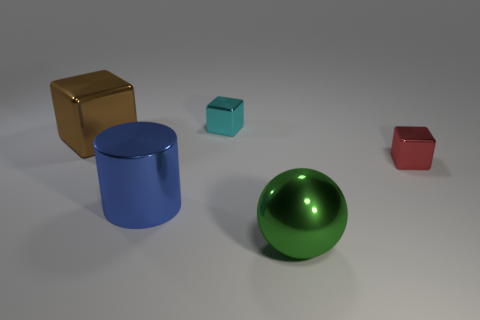Subtract all small cubes. How many cubes are left? 1 Subtract all brown cubes. How many cubes are left? 2 Add 4 brown shiny things. How many objects exist? 9 Subtract all blocks. How many objects are left? 2 Subtract all brown cylinders. How many brown blocks are left? 1 Subtract all tiny purple metallic cylinders. Subtract all tiny cyan objects. How many objects are left? 4 Add 5 green metal things. How many green metal things are left? 6 Add 2 big cylinders. How many big cylinders exist? 3 Subtract 1 green spheres. How many objects are left? 4 Subtract all red blocks. Subtract all green spheres. How many blocks are left? 2 